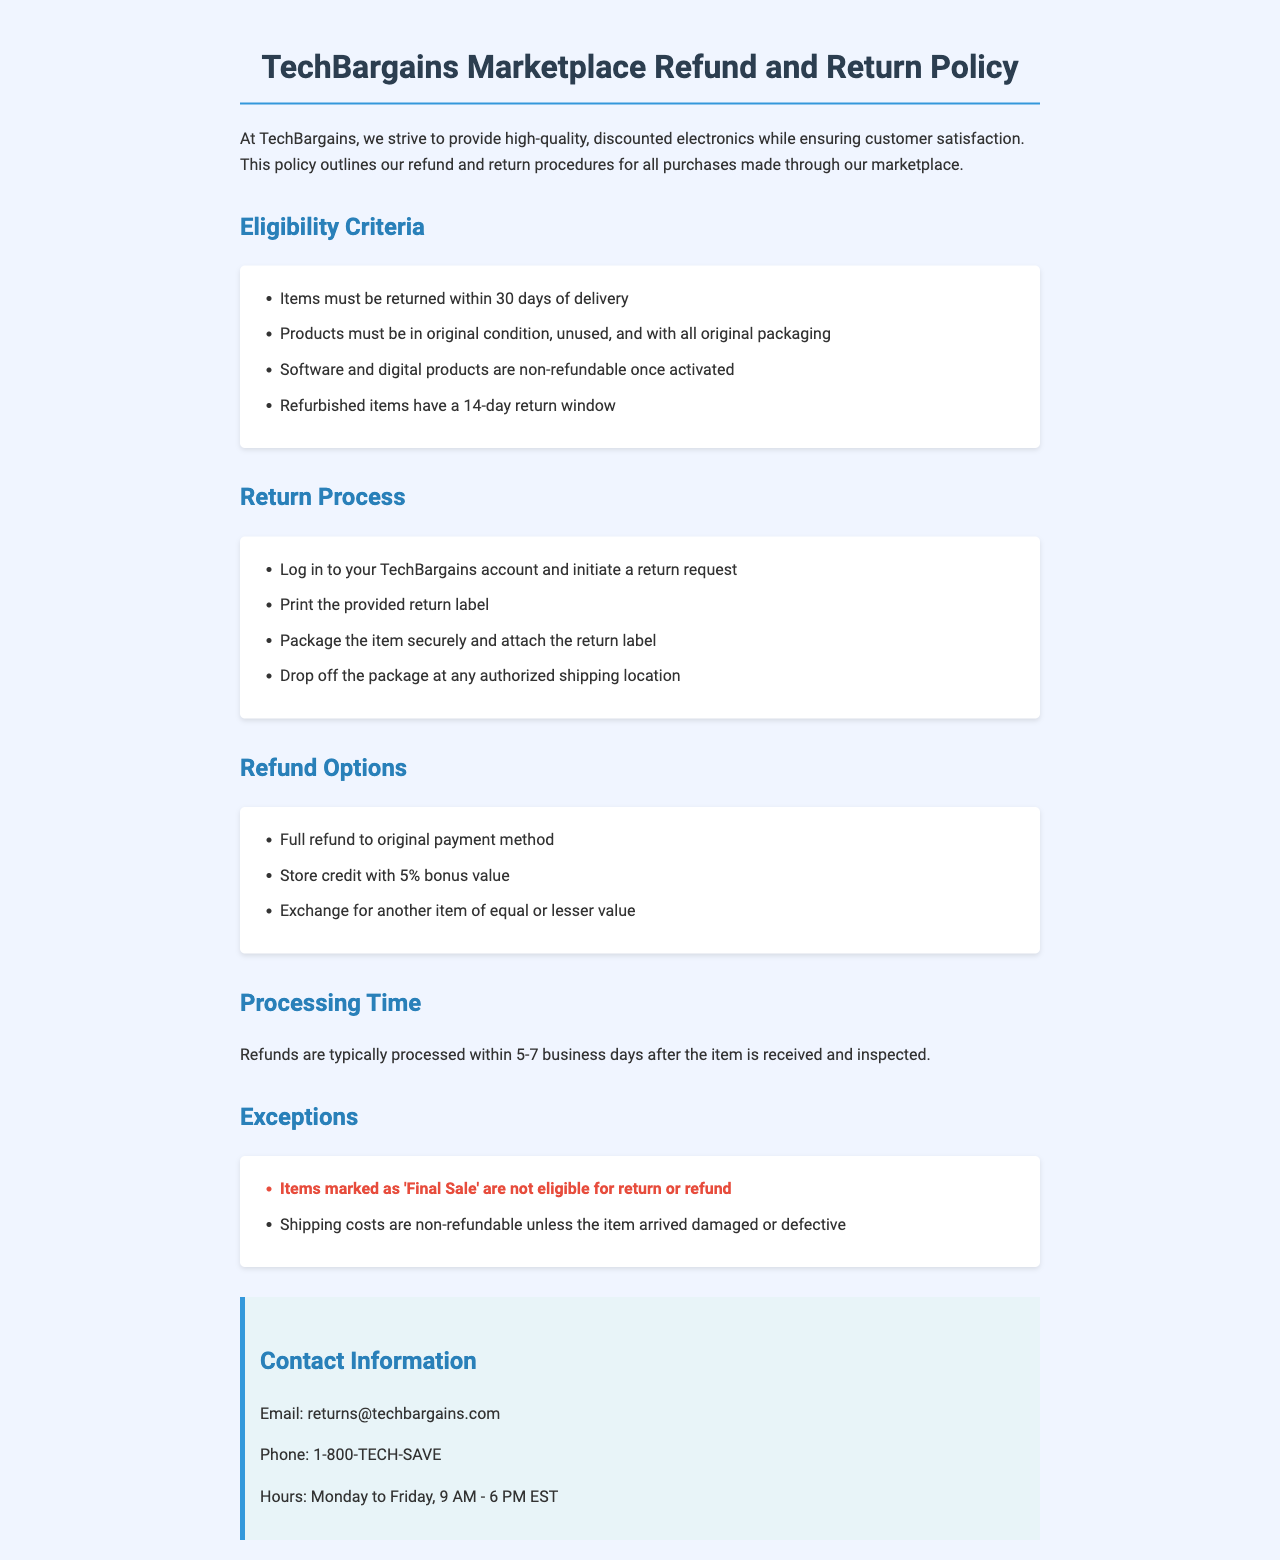What is the return window for items? The return window is specified for general items in the document, cited as 30 days of delivery.
Answer: 30 days What should items be returned with? The document outlines that products must be returned with all original packaging.
Answer: Original packaging Are digital products refundable after activation? The policy specifies that software and digital products are non-refundable once activated.
Answer: Non-refundable What is the bonus value for store credit? The document states that store credit comes with a 5% bonus value.
Answer: 5% What is the processing time for refunds? The document mentions that refunds are typically processed within a specific range of days.
Answer: 5-7 business days What should a customer do to initiate a return? The process requires the customer to log into their account and start a return request.
Answer: Log in to account Which items are not eligible for return? The document highlights that items marked as 'Final Sale' cannot be returned.
Answer: Final Sale What is the customer service email for returns? The document provides an email address for returns inquiries.
Answer: returns@techbargains.com What is the contact phone number? The document lists a specific phone number for customers to reach.
Answer: 1-800-TECH-SAVE 